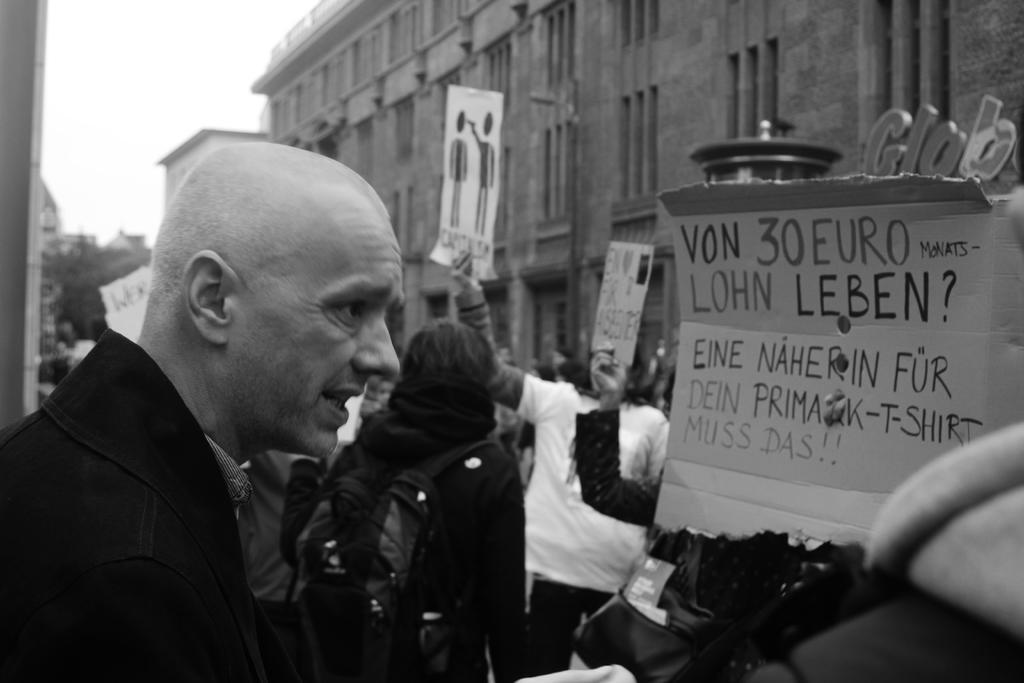Can you describe this image briefly? In the center of the image we can see people standing and holding boards in their hands. In the background there are buildings and sky. 